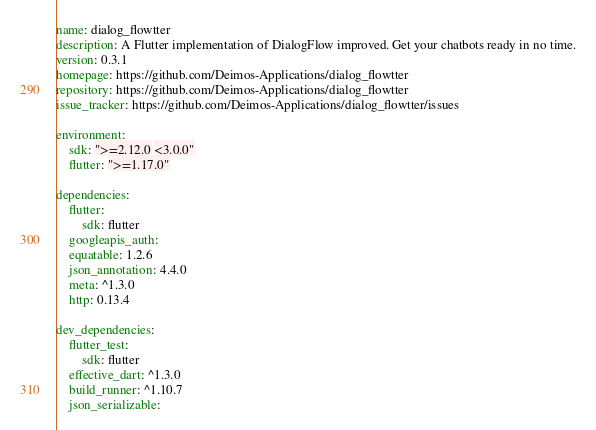<code> <loc_0><loc_0><loc_500><loc_500><_YAML_>name: dialog_flowtter
description: A Flutter implementation of DialogFlow improved. Get your chatbots ready in no time.
version: 0.3.1
homepage: https://github.com/Deimos-Applications/dialog_flowtter
repository: https://github.com/Deimos-Applications/dialog_flowtter
issue_tracker: https://github.com/Deimos-Applications/dialog_flowtter/issues

environment:
    sdk: ">=2.12.0 <3.0.0"
    flutter: ">=1.17.0"

dependencies:
    flutter:
        sdk: flutter
    googleapis_auth:
    equatable: 1.2.6
    json_annotation: 4.4.0
    meta: ^1.3.0
    http: 0.13.4

dev_dependencies:
    flutter_test:
        sdk: flutter
    effective_dart: ^1.3.0
    build_runner: ^1.10.7
    json_serializable:
</code> 